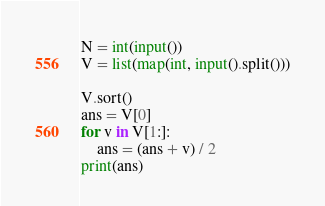Convert code to text. <code><loc_0><loc_0><loc_500><loc_500><_Python_>N = int(input())
V = list(map(int, input().split()))

V.sort()
ans = V[0]
for v in V[1:]:
    ans = (ans + v) / 2
print(ans)</code> 